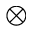Convert formula to latex. <formula><loc_0><loc_0><loc_500><loc_500>\otimes</formula> 